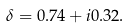Convert formula to latex. <formula><loc_0><loc_0><loc_500><loc_500>\delta = 0 . 7 4 + i 0 . 3 2 .</formula> 